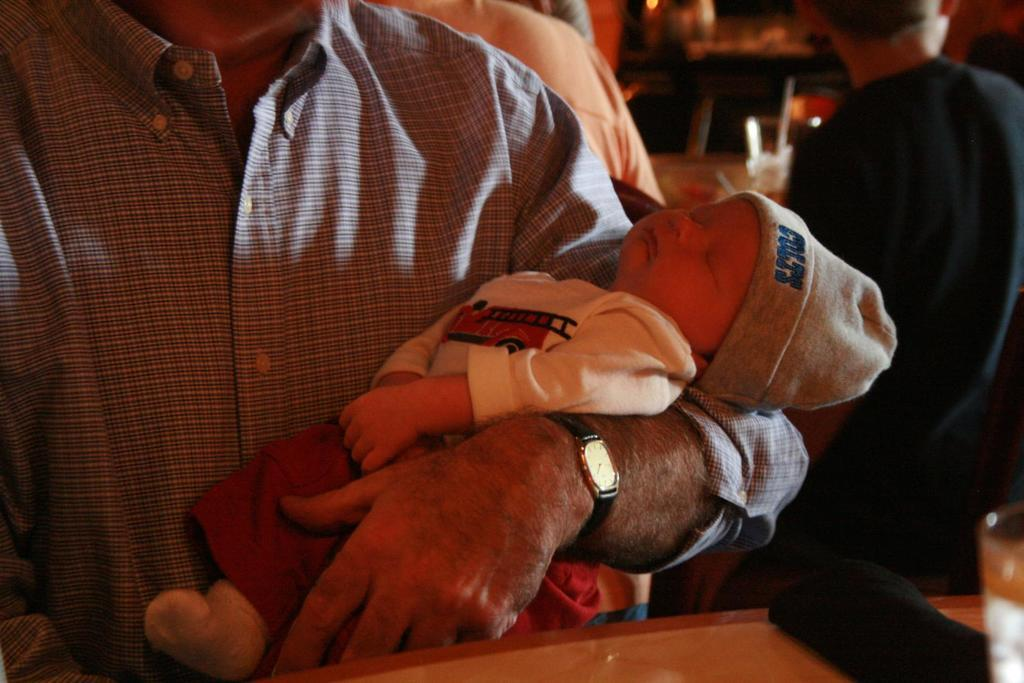<image>
Present a compact description of the photo's key features. A person holding a small baby with a hat on that says Colts on it. 